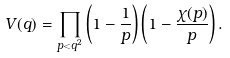<formula> <loc_0><loc_0><loc_500><loc_500>V ( q ) = \prod _ { p < q ^ { 2 } } \left ( 1 - \frac { 1 } { p } \right ) \left ( 1 - \frac { \chi ( p ) } { p } \right ) .</formula> 